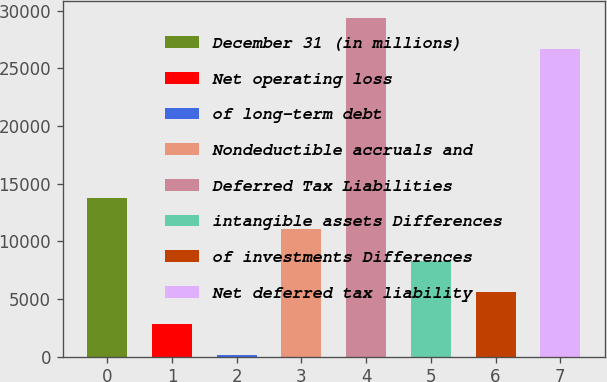Convert chart. <chart><loc_0><loc_0><loc_500><loc_500><bar_chart><fcel>December 31 (in millions)<fcel>Net operating loss<fcel>of long-term debt<fcel>Nondeductible accruals and<fcel>Deferred Tax Liabilities<fcel>intangible assets Differences<fcel>of investments Differences<fcel>Net deferred tax liability<nl><fcel>13753.5<fcel>2873.1<fcel>153<fcel>11033.4<fcel>29410.1<fcel>8313.3<fcel>5593.2<fcel>26690<nl></chart> 